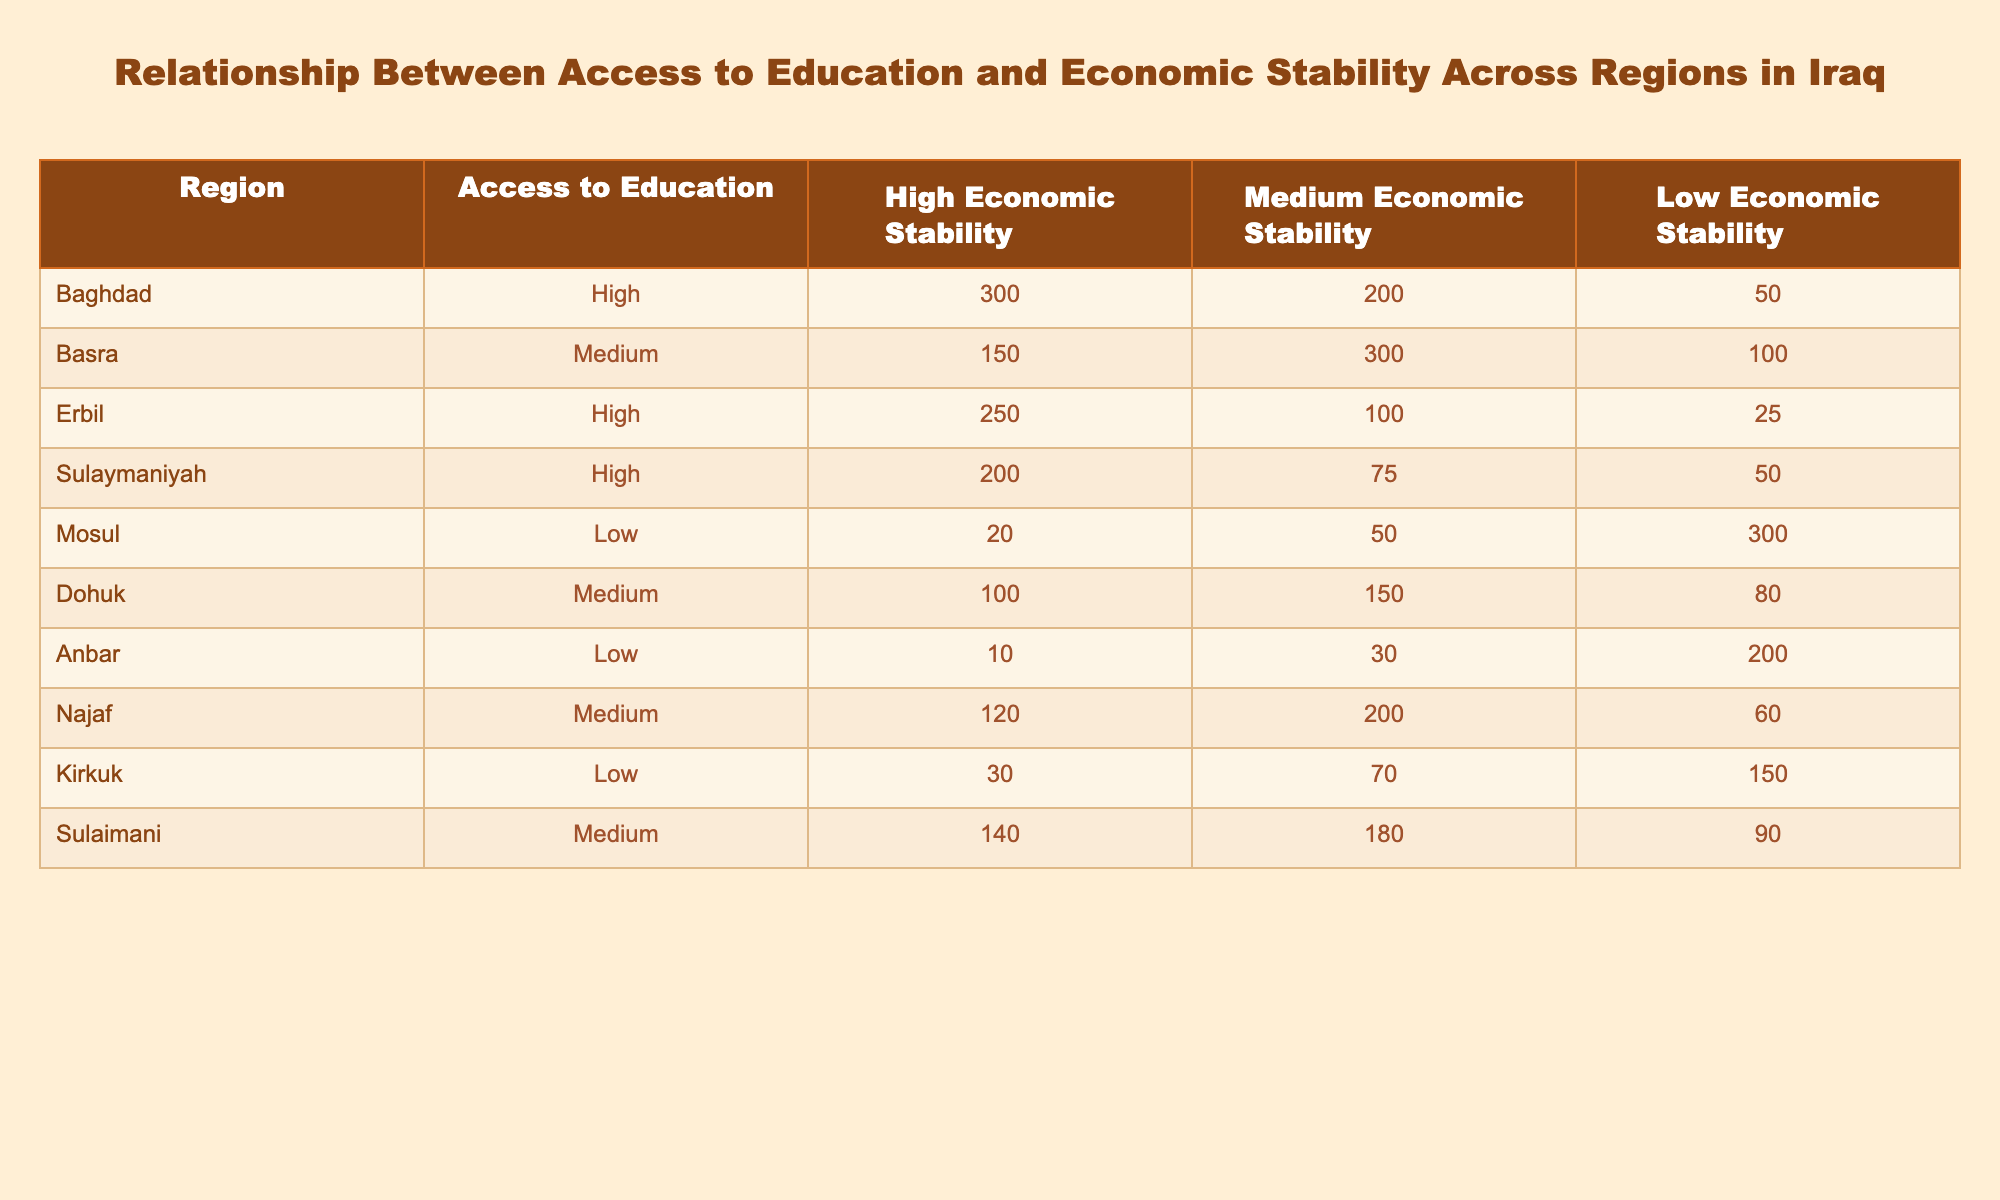What region has the highest number of people with high economic stability? Looking at the table, we see that Baghdad has 300 individuals with high economic stability, which is the highest among all regions listed.
Answer: Baghdad Which region has medium access to education and the highest number of individuals with low economic stability? In the table, Dohuk has medium access to education, with 80 individuals in the low economic stability category. This is the only medium access region, and the count is lower compared to the others with low education access.
Answer: Dohuk What is the total number of individuals across all regions with high economic stability? To find this, we add the values for high economic stability from all regions: 300 (Baghdad) + 150 (Basra) + 250 (Erbil) + 200 (Sulaymaniyah) + 20 (Mosul) + 100 (Dohuk) + 10 (Anbar) + 120 (Najaf) + 30 (Kirkuk) + 140 (Sulaimani) = 1,520.
Answer: 1520 Is it true that Mosul has higher access to education than Anbar? In the table, Mosul is marked as having low access to education, while Anbar is also marked as low. Hence, they do not differ in terms of access to education.
Answer: No What is the average number of individuals with medium economic stability in regions with high access to education? High access to education regions are Baghdad, Erbil, and Sulaymaniyah. The corresponding medium economic stability counts are: 200 (Baghdad), 100 (Erbil), and 75 (Sulaymaniyah). Summing these gives 200 + 100 + 75 = 375. There are 3 regions, so the average is 375 / 3 = 125.
Answer: 125 Which region has the lowest number of people with low economic stability? In the table, the region with the lowest number of individuals in the low economic stability column is Erbil, which has only 25 individuals.
Answer: Erbil What is the difference between the number of individuals with high economic stability in Baghdad and Basra? From the table, Baghdad has 300 individuals with high economic stability, while Basra has 150. The difference is calculated as 300 - 150 = 150.
Answer: 150 Is there any region with high access to education and low economic stability? Reviewing the table, it's clear that Erbil, Sulaymaniyah, and Baghdad all have high access to education, but none of these regions report any figures in the low economic stability category that are comparable to the ones in medium or high.
Answer: No What is the total number of people with access to medium education in Kirkuk and Anbar? Kirkuk has 70 individuals in medium economic stability, while Anbar has 30. The total is 70 + 30 = 100.
Answer: 100 